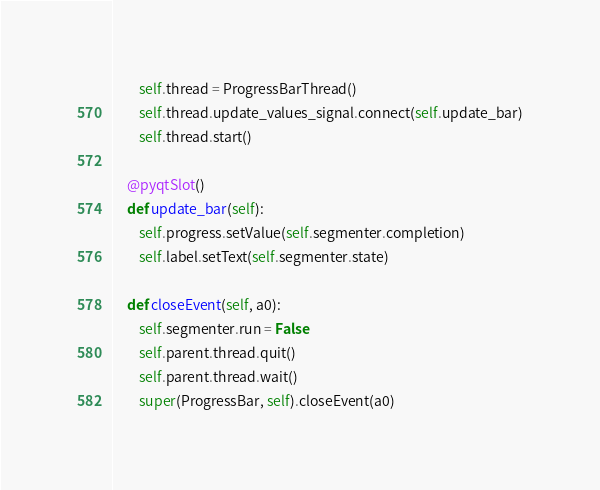<code> <loc_0><loc_0><loc_500><loc_500><_Python_>        self.thread = ProgressBarThread()
        self.thread.update_values_signal.connect(self.update_bar)
        self.thread.start()

    @pyqtSlot()
    def update_bar(self):
        self.progress.setValue(self.segmenter.completion)
        self.label.setText(self.segmenter.state)

    def closeEvent(self, a0):
        self.segmenter.run = False
        self.parent.thread.quit()
        self.parent.thread.wait()
        super(ProgressBar, self).closeEvent(a0)
</code> 